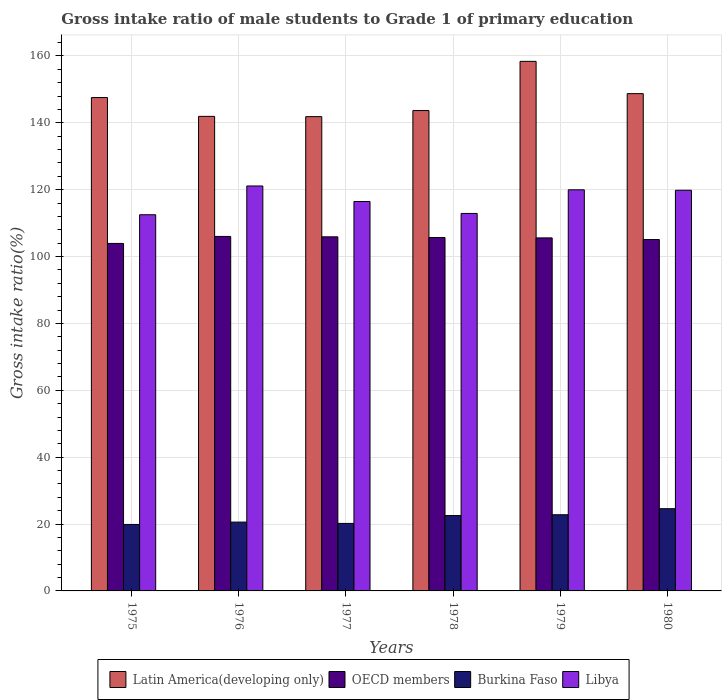Are the number of bars on each tick of the X-axis equal?
Your response must be concise. Yes. What is the label of the 1st group of bars from the left?
Keep it short and to the point. 1975. In how many cases, is the number of bars for a given year not equal to the number of legend labels?
Provide a short and direct response. 0. What is the gross intake ratio in Libya in 1979?
Make the answer very short. 119.96. Across all years, what is the maximum gross intake ratio in Libya?
Offer a very short reply. 121.1. Across all years, what is the minimum gross intake ratio in Burkina Faso?
Your answer should be compact. 19.88. In which year was the gross intake ratio in Libya maximum?
Make the answer very short. 1976. In which year was the gross intake ratio in Burkina Faso minimum?
Your answer should be very brief. 1975. What is the total gross intake ratio in Latin America(developing only) in the graph?
Your answer should be very brief. 882.04. What is the difference between the gross intake ratio in Latin America(developing only) in 1976 and that in 1980?
Your response must be concise. -6.8. What is the difference between the gross intake ratio in Burkina Faso in 1977 and the gross intake ratio in Libya in 1980?
Ensure brevity in your answer.  -99.63. What is the average gross intake ratio in OECD members per year?
Your answer should be very brief. 105.36. In the year 1976, what is the difference between the gross intake ratio in Burkina Faso and gross intake ratio in Libya?
Give a very brief answer. -100.52. In how many years, is the gross intake ratio in Latin America(developing only) greater than 128 %?
Keep it short and to the point. 6. What is the ratio of the gross intake ratio in Burkina Faso in 1979 to that in 1980?
Your answer should be very brief. 0.93. Is the gross intake ratio in Burkina Faso in 1978 less than that in 1979?
Your response must be concise. Yes. What is the difference between the highest and the second highest gross intake ratio in Libya?
Ensure brevity in your answer.  1.14. What is the difference between the highest and the lowest gross intake ratio in Libya?
Your answer should be very brief. 8.6. In how many years, is the gross intake ratio in Latin America(developing only) greater than the average gross intake ratio in Latin America(developing only) taken over all years?
Make the answer very short. 3. Is the sum of the gross intake ratio in OECD members in 1979 and 1980 greater than the maximum gross intake ratio in Burkina Faso across all years?
Offer a very short reply. Yes. What does the 4th bar from the right in 1978 represents?
Provide a succinct answer. Latin America(developing only). Is it the case that in every year, the sum of the gross intake ratio in OECD members and gross intake ratio in Latin America(developing only) is greater than the gross intake ratio in Burkina Faso?
Your answer should be very brief. Yes. Are all the bars in the graph horizontal?
Your answer should be compact. No. How many years are there in the graph?
Provide a succinct answer. 6. Does the graph contain grids?
Keep it short and to the point. Yes. How are the legend labels stacked?
Ensure brevity in your answer.  Horizontal. What is the title of the graph?
Provide a succinct answer. Gross intake ratio of male students to Grade 1 of primary education. Does "Madagascar" appear as one of the legend labels in the graph?
Make the answer very short. No. What is the label or title of the Y-axis?
Give a very brief answer. Gross intake ratio(%). What is the Gross intake ratio(%) in Latin America(developing only) in 1975?
Your answer should be compact. 147.54. What is the Gross intake ratio(%) of OECD members in 1975?
Provide a succinct answer. 103.92. What is the Gross intake ratio(%) of Burkina Faso in 1975?
Provide a short and direct response. 19.88. What is the Gross intake ratio(%) of Libya in 1975?
Ensure brevity in your answer.  112.5. What is the Gross intake ratio(%) of Latin America(developing only) in 1976?
Keep it short and to the point. 141.92. What is the Gross intake ratio(%) in OECD members in 1976?
Keep it short and to the point. 106.01. What is the Gross intake ratio(%) in Burkina Faso in 1976?
Make the answer very short. 20.58. What is the Gross intake ratio(%) of Libya in 1976?
Ensure brevity in your answer.  121.1. What is the Gross intake ratio(%) of Latin America(developing only) in 1977?
Your response must be concise. 141.84. What is the Gross intake ratio(%) in OECD members in 1977?
Give a very brief answer. 105.89. What is the Gross intake ratio(%) of Burkina Faso in 1977?
Make the answer very short. 20.19. What is the Gross intake ratio(%) in Libya in 1977?
Your answer should be compact. 116.46. What is the Gross intake ratio(%) in Latin America(developing only) in 1978?
Give a very brief answer. 143.65. What is the Gross intake ratio(%) in OECD members in 1978?
Your answer should be compact. 105.68. What is the Gross intake ratio(%) in Burkina Faso in 1978?
Your answer should be compact. 22.54. What is the Gross intake ratio(%) of Libya in 1978?
Provide a succinct answer. 112.89. What is the Gross intake ratio(%) of Latin America(developing only) in 1979?
Provide a succinct answer. 158.37. What is the Gross intake ratio(%) of OECD members in 1979?
Provide a succinct answer. 105.57. What is the Gross intake ratio(%) of Burkina Faso in 1979?
Make the answer very short. 22.78. What is the Gross intake ratio(%) of Libya in 1979?
Provide a succinct answer. 119.96. What is the Gross intake ratio(%) in Latin America(developing only) in 1980?
Your answer should be very brief. 148.72. What is the Gross intake ratio(%) in OECD members in 1980?
Offer a terse response. 105.08. What is the Gross intake ratio(%) of Burkina Faso in 1980?
Make the answer very short. 24.59. What is the Gross intake ratio(%) of Libya in 1980?
Ensure brevity in your answer.  119.82. Across all years, what is the maximum Gross intake ratio(%) in Latin America(developing only)?
Make the answer very short. 158.37. Across all years, what is the maximum Gross intake ratio(%) in OECD members?
Your answer should be compact. 106.01. Across all years, what is the maximum Gross intake ratio(%) in Burkina Faso?
Provide a short and direct response. 24.59. Across all years, what is the maximum Gross intake ratio(%) in Libya?
Offer a terse response. 121.1. Across all years, what is the minimum Gross intake ratio(%) of Latin America(developing only)?
Make the answer very short. 141.84. Across all years, what is the minimum Gross intake ratio(%) in OECD members?
Ensure brevity in your answer.  103.92. Across all years, what is the minimum Gross intake ratio(%) of Burkina Faso?
Your answer should be compact. 19.88. Across all years, what is the minimum Gross intake ratio(%) in Libya?
Your answer should be very brief. 112.5. What is the total Gross intake ratio(%) of Latin America(developing only) in the graph?
Your answer should be very brief. 882.04. What is the total Gross intake ratio(%) of OECD members in the graph?
Your answer should be very brief. 632.16. What is the total Gross intake ratio(%) of Burkina Faso in the graph?
Make the answer very short. 130.56. What is the total Gross intake ratio(%) of Libya in the graph?
Give a very brief answer. 702.72. What is the difference between the Gross intake ratio(%) in Latin America(developing only) in 1975 and that in 1976?
Provide a short and direct response. 5.63. What is the difference between the Gross intake ratio(%) of OECD members in 1975 and that in 1976?
Your response must be concise. -2.09. What is the difference between the Gross intake ratio(%) in Burkina Faso in 1975 and that in 1976?
Offer a terse response. -0.7. What is the difference between the Gross intake ratio(%) in Libya in 1975 and that in 1976?
Your answer should be compact. -8.6. What is the difference between the Gross intake ratio(%) in Latin America(developing only) in 1975 and that in 1977?
Offer a terse response. 5.7. What is the difference between the Gross intake ratio(%) of OECD members in 1975 and that in 1977?
Keep it short and to the point. -1.97. What is the difference between the Gross intake ratio(%) of Burkina Faso in 1975 and that in 1977?
Provide a short and direct response. -0.31. What is the difference between the Gross intake ratio(%) of Libya in 1975 and that in 1977?
Offer a terse response. -3.96. What is the difference between the Gross intake ratio(%) of Latin America(developing only) in 1975 and that in 1978?
Make the answer very short. 3.89. What is the difference between the Gross intake ratio(%) in OECD members in 1975 and that in 1978?
Give a very brief answer. -1.76. What is the difference between the Gross intake ratio(%) in Burkina Faso in 1975 and that in 1978?
Offer a terse response. -2.66. What is the difference between the Gross intake ratio(%) of Libya in 1975 and that in 1978?
Offer a terse response. -0.39. What is the difference between the Gross intake ratio(%) in Latin America(developing only) in 1975 and that in 1979?
Provide a short and direct response. -10.83. What is the difference between the Gross intake ratio(%) in OECD members in 1975 and that in 1979?
Ensure brevity in your answer.  -1.65. What is the difference between the Gross intake ratio(%) in Burkina Faso in 1975 and that in 1979?
Provide a succinct answer. -2.9. What is the difference between the Gross intake ratio(%) in Libya in 1975 and that in 1979?
Provide a succinct answer. -7.45. What is the difference between the Gross intake ratio(%) in Latin America(developing only) in 1975 and that in 1980?
Your response must be concise. -1.17. What is the difference between the Gross intake ratio(%) in OECD members in 1975 and that in 1980?
Offer a very short reply. -1.16. What is the difference between the Gross intake ratio(%) of Burkina Faso in 1975 and that in 1980?
Make the answer very short. -4.71. What is the difference between the Gross intake ratio(%) of Libya in 1975 and that in 1980?
Give a very brief answer. -7.32. What is the difference between the Gross intake ratio(%) of Latin America(developing only) in 1976 and that in 1977?
Give a very brief answer. 0.08. What is the difference between the Gross intake ratio(%) of OECD members in 1976 and that in 1977?
Offer a very short reply. 0.12. What is the difference between the Gross intake ratio(%) in Burkina Faso in 1976 and that in 1977?
Your response must be concise. 0.4. What is the difference between the Gross intake ratio(%) of Libya in 1976 and that in 1977?
Keep it short and to the point. 4.64. What is the difference between the Gross intake ratio(%) in Latin America(developing only) in 1976 and that in 1978?
Offer a terse response. -1.74. What is the difference between the Gross intake ratio(%) of OECD members in 1976 and that in 1978?
Ensure brevity in your answer.  0.33. What is the difference between the Gross intake ratio(%) of Burkina Faso in 1976 and that in 1978?
Keep it short and to the point. -1.95. What is the difference between the Gross intake ratio(%) of Libya in 1976 and that in 1978?
Your response must be concise. 8.21. What is the difference between the Gross intake ratio(%) of Latin America(developing only) in 1976 and that in 1979?
Give a very brief answer. -16.45. What is the difference between the Gross intake ratio(%) in OECD members in 1976 and that in 1979?
Your response must be concise. 0.44. What is the difference between the Gross intake ratio(%) in Burkina Faso in 1976 and that in 1979?
Keep it short and to the point. -2.2. What is the difference between the Gross intake ratio(%) in Libya in 1976 and that in 1979?
Your answer should be compact. 1.14. What is the difference between the Gross intake ratio(%) in Latin America(developing only) in 1976 and that in 1980?
Keep it short and to the point. -6.8. What is the difference between the Gross intake ratio(%) in Burkina Faso in 1976 and that in 1980?
Offer a terse response. -4.01. What is the difference between the Gross intake ratio(%) of Libya in 1976 and that in 1980?
Your answer should be very brief. 1.28. What is the difference between the Gross intake ratio(%) of Latin America(developing only) in 1977 and that in 1978?
Provide a short and direct response. -1.81. What is the difference between the Gross intake ratio(%) in OECD members in 1977 and that in 1978?
Make the answer very short. 0.21. What is the difference between the Gross intake ratio(%) of Burkina Faso in 1977 and that in 1978?
Provide a short and direct response. -2.35. What is the difference between the Gross intake ratio(%) in Libya in 1977 and that in 1978?
Your answer should be very brief. 3.57. What is the difference between the Gross intake ratio(%) of Latin America(developing only) in 1977 and that in 1979?
Provide a short and direct response. -16.53. What is the difference between the Gross intake ratio(%) of OECD members in 1977 and that in 1979?
Provide a short and direct response. 0.32. What is the difference between the Gross intake ratio(%) of Burkina Faso in 1977 and that in 1979?
Keep it short and to the point. -2.6. What is the difference between the Gross intake ratio(%) of Libya in 1977 and that in 1979?
Your response must be concise. -3.5. What is the difference between the Gross intake ratio(%) in Latin America(developing only) in 1977 and that in 1980?
Keep it short and to the point. -6.88. What is the difference between the Gross intake ratio(%) of OECD members in 1977 and that in 1980?
Provide a succinct answer. 0.81. What is the difference between the Gross intake ratio(%) in Burkina Faso in 1977 and that in 1980?
Ensure brevity in your answer.  -4.4. What is the difference between the Gross intake ratio(%) in Libya in 1977 and that in 1980?
Your answer should be compact. -3.36. What is the difference between the Gross intake ratio(%) in Latin America(developing only) in 1978 and that in 1979?
Make the answer very short. -14.72. What is the difference between the Gross intake ratio(%) of Burkina Faso in 1978 and that in 1979?
Your answer should be compact. -0.24. What is the difference between the Gross intake ratio(%) in Libya in 1978 and that in 1979?
Provide a succinct answer. -7.07. What is the difference between the Gross intake ratio(%) of Latin America(developing only) in 1978 and that in 1980?
Offer a terse response. -5.06. What is the difference between the Gross intake ratio(%) in OECD members in 1978 and that in 1980?
Offer a very short reply. 0.6. What is the difference between the Gross intake ratio(%) of Burkina Faso in 1978 and that in 1980?
Offer a very short reply. -2.05. What is the difference between the Gross intake ratio(%) of Libya in 1978 and that in 1980?
Keep it short and to the point. -6.93. What is the difference between the Gross intake ratio(%) of Latin America(developing only) in 1979 and that in 1980?
Your answer should be very brief. 9.65. What is the difference between the Gross intake ratio(%) in OECD members in 1979 and that in 1980?
Provide a succinct answer. 0.49. What is the difference between the Gross intake ratio(%) of Burkina Faso in 1979 and that in 1980?
Ensure brevity in your answer.  -1.81. What is the difference between the Gross intake ratio(%) of Libya in 1979 and that in 1980?
Provide a short and direct response. 0.13. What is the difference between the Gross intake ratio(%) of Latin America(developing only) in 1975 and the Gross intake ratio(%) of OECD members in 1976?
Provide a succinct answer. 41.53. What is the difference between the Gross intake ratio(%) in Latin America(developing only) in 1975 and the Gross intake ratio(%) in Burkina Faso in 1976?
Your answer should be compact. 126.96. What is the difference between the Gross intake ratio(%) in Latin America(developing only) in 1975 and the Gross intake ratio(%) in Libya in 1976?
Make the answer very short. 26.44. What is the difference between the Gross intake ratio(%) in OECD members in 1975 and the Gross intake ratio(%) in Burkina Faso in 1976?
Your answer should be very brief. 83.34. What is the difference between the Gross intake ratio(%) in OECD members in 1975 and the Gross intake ratio(%) in Libya in 1976?
Offer a terse response. -17.18. What is the difference between the Gross intake ratio(%) in Burkina Faso in 1975 and the Gross intake ratio(%) in Libya in 1976?
Your answer should be compact. -101.22. What is the difference between the Gross intake ratio(%) in Latin America(developing only) in 1975 and the Gross intake ratio(%) in OECD members in 1977?
Your response must be concise. 41.65. What is the difference between the Gross intake ratio(%) in Latin America(developing only) in 1975 and the Gross intake ratio(%) in Burkina Faso in 1977?
Keep it short and to the point. 127.36. What is the difference between the Gross intake ratio(%) of Latin America(developing only) in 1975 and the Gross intake ratio(%) of Libya in 1977?
Your response must be concise. 31.08. What is the difference between the Gross intake ratio(%) of OECD members in 1975 and the Gross intake ratio(%) of Burkina Faso in 1977?
Your answer should be very brief. 83.73. What is the difference between the Gross intake ratio(%) in OECD members in 1975 and the Gross intake ratio(%) in Libya in 1977?
Your response must be concise. -12.54. What is the difference between the Gross intake ratio(%) of Burkina Faso in 1975 and the Gross intake ratio(%) of Libya in 1977?
Offer a very short reply. -96.58. What is the difference between the Gross intake ratio(%) in Latin America(developing only) in 1975 and the Gross intake ratio(%) in OECD members in 1978?
Give a very brief answer. 41.86. What is the difference between the Gross intake ratio(%) of Latin America(developing only) in 1975 and the Gross intake ratio(%) of Burkina Faso in 1978?
Provide a succinct answer. 125. What is the difference between the Gross intake ratio(%) in Latin America(developing only) in 1975 and the Gross intake ratio(%) in Libya in 1978?
Provide a short and direct response. 34.66. What is the difference between the Gross intake ratio(%) in OECD members in 1975 and the Gross intake ratio(%) in Burkina Faso in 1978?
Offer a very short reply. 81.38. What is the difference between the Gross intake ratio(%) of OECD members in 1975 and the Gross intake ratio(%) of Libya in 1978?
Make the answer very short. -8.97. What is the difference between the Gross intake ratio(%) in Burkina Faso in 1975 and the Gross intake ratio(%) in Libya in 1978?
Make the answer very short. -93.01. What is the difference between the Gross intake ratio(%) in Latin America(developing only) in 1975 and the Gross intake ratio(%) in OECD members in 1979?
Your response must be concise. 41.97. What is the difference between the Gross intake ratio(%) in Latin America(developing only) in 1975 and the Gross intake ratio(%) in Burkina Faso in 1979?
Offer a very short reply. 124.76. What is the difference between the Gross intake ratio(%) in Latin America(developing only) in 1975 and the Gross intake ratio(%) in Libya in 1979?
Make the answer very short. 27.59. What is the difference between the Gross intake ratio(%) of OECD members in 1975 and the Gross intake ratio(%) of Burkina Faso in 1979?
Offer a terse response. 81.14. What is the difference between the Gross intake ratio(%) in OECD members in 1975 and the Gross intake ratio(%) in Libya in 1979?
Keep it short and to the point. -16.04. What is the difference between the Gross intake ratio(%) of Burkina Faso in 1975 and the Gross intake ratio(%) of Libya in 1979?
Your answer should be compact. -100.07. What is the difference between the Gross intake ratio(%) of Latin America(developing only) in 1975 and the Gross intake ratio(%) of OECD members in 1980?
Give a very brief answer. 42.46. What is the difference between the Gross intake ratio(%) of Latin America(developing only) in 1975 and the Gross intake ratio(%) of Burkina Faso in 1980?
Offer a very short reply. 122.95. What is the difference between the Gross intake ratio(%) in Latin America(developing only) in 1975 and the Gross intake ratio(%) in Libya in 1980?
Your answer should be very brief. 27.72. What is the difference between the Gross intake ratio(%) of OECD members in 1975 and the Gross intake ratio(%) of Burkina Faso in 1980?
Make the answer very short. 79.33. What is the difference between the Gross intake ratio(%) in OECD members in 1975 and the Gross intake ratio(%) in Libya in 1980?
Offer a very short reply. -15.9. What is the difference between the Gross intake ratio(%) in Burkina Faso in 1975 and the Gross intake ratio(%) in Libya in 1980?
Your answer should be compact. -99.94. What is the difference between the Gross intake ratio(%) of Latin America(developing only) in 1976 and the Gross intake ratio(%) of OECD members in 1977?
Offer a terse response. 36.02. What is the difference between the Gross intake ratio(%) in Latin America(developing only) in 1976 and the Gross intake ratio(%) in Burkina Faso in 1977?
Make the answer very short. 121.73. What is the difference between the Gross intake ratio(%) of Latin America(developing only) in 1976 and the Gross intake ratio(%) of Libya in 1977?
Keep it short and to the point. 25.46. What is the difference between the Gross intake ratio(%) in OECD members in 1976 and the Gross intake ratio(%) in Burkina Faso in 1977?
Make the answer very short. 85.83. What is the difference between the Gross intake ratio(%) in OECD members in 1976 and the Gross intake ratio(%) in Libya in 1977?
Offer a terse response. -10.45. What is the difference between the Gross intake ratio(%) in Burkina Faso in 1976 and the Gross intake ratio(%) in Libya in 1977?
Offer a terse response. -95.88. What is the difference between the Gross intake ratio(%) in Latin America(developing only) in 1976 and the Gross intake ratio(%) in OECD members in 1978?
Offer a terse response. 36.23. What is the difference between the Gross intake ratio(%) of Latin America(developing only) in 1976 and the Gross intake ratio(%) of Burkina Faso in 1978?
Provide a succinct answer. 119.38. What is the difference between the Gross intake ratio(%) in Latin America(developing only) in 1976 and the Gross intake ratio(%) in Libya in 1978?
Keep it short and to the point. 29.03. What is the difference between the Gross intake ratio(%) in OECD members in 1976 and the Gross intake ratio(%) in Burkina Faso in 1978?
Your answer should be very brief. 83.47. What is the difference between the Gross intake ratio(%) in OECD members in 1976 and the Gross intake ratio(%) in Libya in 1978?
Your answer should be very brief. -6.88. What is the difference between the Gross intake ratio(%) of Burkina Faso in 1976 and the Gross intake ratio(%) of Libya in 1978?
Your answer should be compact. -92.3. What is the difference between the Gross intake ratio(%) of Latin America(developing only) in 1976 and the Gross intake ratio(%) of OECD members in 1979?
Make the answer very short. 36.34. What is the difference between the Gross intake ratio(%) of Latin America(developing only) in 1976 and the Gross intake ratio(%) of Burkina Faso in 1979?
Keep it short and to the point. 119.14. What is the difference between the Gross intake ratio(%) of Latin America(developing only) in 1976 and the Gross intake ratio(%) of Libya in 1979?
Provide a short and direct response. 21.96. What is the difference between the Gross intake ratio(%) in OECD members in 1976 and the Gross intake ratio(%) in Burkina Faso in 1979?
Ensure brevity in your answer.  83.23. What is the difference between the Gross intake ratio(%) in OECD members in 1976 and the Gross intake ratio(%) in Libya in 1979?
Give a very brief answer. -13.94. What is the difference between the Gross intake ratio(%) of Burkina Faso in 1976 and the Gross intake ratio(%) of Libya in 1979?
Keep it short and to the point. -99.37. What is the difference between the Gross intake ratio(%) of Latin America(developing only) in 1976 and the Gross intake ratio(%) of OECD members in 1980?
Offer a terse response. 36.83. What is the difference between the Gross intake ratio(%) of Latin America(developing only) in 1976 and the Gross intake ratio(%) of Burkina Faso in 1980?
Your response must be concise. 117.33. What is the difference between the Gross intake ratio(%) of Latin America(developing only) in 1976 and the Gross intake ratio(%) of Libya in 1980?
Ensure brevity in your answer.  22.1. What is the difference between the Gross intake ratio(%) in OECD members in 1976 and the Gross intake ratio(%) in Burkina Faso in 1980?
Provide a succinct answer. 81.42. What is the difference between the Gross intake ratio(%) in OECD members in 1976 and the Gross intake ratio(%) in Libya in 1980?
Give a very brief answer. -13.81. What is the difference between the Gross intake ratio(%) in Burkina Faso in 1976 and the Gross intake ratio(%) in Libya in 1980?
Provide a short and direct response. -99.24. What is the difference between the Gross intake ratio(%) of Latin America(developing only) in 1977 and the Gross intake ratio(%) of OECD members in 1978?
Make the answer very short. 36.16. What is the difference between the Gross intake ratio(%) of Latin America(developing only) in 1977 and the Gross intake ratio(%) of Burkina Faso in 1978?
Keep it short and to the point. 119.3. What is the difference between the Gross intake ratio(%) in Latin America(developing only) in 1977 and the Gross intake ratio(%) in Libya in 1978?
Your response must be concise. 28.95. What is the difference between the Gross intake ratio(%) of OECD members in 1977 and the Gross intake ratio(%) of Burkina Faso in 1978?
Your response must be concise. 83.35. What is the difference between the Gross intake ratio(%) of OECD members in 1977 and the Gross intake ratio(%) of Libya in 1978?
Your answer should be very brief. -6.99. What is the difference between the Gross intake ratio(%) of Burkina Faso in 1977 and the Gross intake ratio(%) of Libya in 1978?
Offer a very short reply. -92.7. What is the difference between the Gross intake ratio(%) of Latin America(developing only) in 1977 and the Gross intake ratio(%) of OECD members in 1979?
Make the answer very short. 36.27. What is the difference between the Gross intake ratio(%) in Latin America(developing only) in 1977 and the Gross intake ratio(%) in Burkina Faso in 1979?
Provide a succinct answer. 119.06. What is the difference between the Gross intake ratio(%) of Latin America(developing only) in 1977 and the Gross intake ratio(%) of Libya in 1979?
Provide a short and direct response. 21.89. What is the difference between the Gross intake ratio(%) in OECD members in 1977 and the Gross intake ratio(%) in Burkina Faso in 1979?
Make the answer very short. 83.11. What is the difference between the Gross intake ratio(%) in OECD members in 1977 and the Gross intake ratio(%) in Libya in 1979?
Ensure brevity in your answer.  -14.06. What is the difference between the Gross intake ratio(%) in Burkina Faso in 1977 and the Gross intake ratio(%) in Libya in 1979?
Offer a very short reply. -99.77. What is the difference between the Gross intake ratio(%) in Latin America(developing only) in 1977 and the Gross intake ratio(%) in OECD members in 1980?
Make the answer very short. 36.76. What is the difference between the Gross intake ratio(%) in Latin America(developing only) in 1977 and the Gross intake ratio(%) in Burkina Faso in 1980?
Provide a succinct answer. 117.25. What is the difference between the Gross intake ratio(%) of Latin America(developing only) in 1977 and the Gross intake ratio(%) of Libya in 1980?
Give a very brief answer. 22.02. What is the difference between the Gross intake ratio(%) in OECD members in 1977 and the Gross intake ratio(%) in Burkina Faso in 1980?
Provide a succinct answer. 81.3. What is the difference between the Gross intake ratio(%) of OECD members in 1977 and the Gross intake ratio(%) of Libya in 1980?
Provide a succinct answer. -13.93. What is the difference between the Gross intake ratio(%) in Burkina Faso in 1977 and the Gross intake ratio(%) in Libya in 1980?
Your answer should be very brief. -99.63. What is the difference between the Gross intake ratio(%) in Latin America(developing only) in 1978 and the Gross intake ratio(%) in OECD members in 1979?
Provide a short and direct response. 38.08. What is the difference between the Gross intake ratio(%) in Latin America(developing only) in 1978 and the Gross intake ratio(%) in Burkina Faso in 1979?
Keep it short and to the point. 120.87. What is the difference between the Gross intake ratio(%) in Latin America(developing only) in 1978 and the Gross intake ratio(%) in Libya in 1979?
Offer a very short reply. 23.7. What is the difference between the Gross intake ratio(%) in OECD members in 1978 and the Gross intake ratio(%) in Burkina Faso in 1979?
Make the answer very short. 82.9. What is the difference between the Gross intake ratio(%) in OECD members in 1978 and the Gross intake ratio(%) in Libya in 1979?
Your response must be concise. -14.27. What is the difference between the Gross intake ratio(%) in Burkina Faso in 1978 and the Gross intake ratio(%) in Libya in 1979?
Give a very brief answer. -97.42. What is the difference between the Gross intake ratio(%) of Latin America(developing only) in 1978 and the Gross intake ratio(%) of OECD members in 1980?
Provide a short and direct response. 38.57. What is the difference between the Gross intake ratio(%) in Latin America(developing only) in 1978 and the Gross intake ratio(%) in Burkina Faso in 1980?
Give a very brief answer. 119.06. What is the difference between the Gross intake ratio(%) in Latin America(developing only) in 1978 and the Gross intake ratio(%) in Libya in 1980?
Offer a terse response. 23.83. What is the difference between the Gross intake ratio(%) in OECD members in 1978 and the Gross intake ratio(%) in Burkina Faso in 1980?
Ensure brevity in your answer.  81.09. What is the difference between the Gross intake ratio(%) in OECD members in 1978 and the Gross intake ratio(%) in Libya in 1980?
Your answer should be very brief. -14.14. What is the difference between the Gross intake ratio(%) of Burkina Faso in 1978 and the Gross intake ratio(%) of Libya in 1980?
Your answer should be very brief. -97.28. What is the difference between the Gross intake ratio(%) of Latin America(developing only) in 1979 and the Gross intake ratio(%) of OECD members in 1980?
Offer a terse response. 53.29. What is the difference between the Gross intake ratio(%) of Latin America(developing only) in 1979 and the Gross intake ratio(%) of Burkina Faso in 1980?
Offer a very short reply. 133.78. What is the difference between the Gross intake ratio(%) of Latin America(developing only) in 1979 and the Gross intake ratio(%) of Libya in 1980?
Your response must be concise. 38.55. What is the difference between the Gross intake ratio(%) in OECD members in 1979 and the Gross intake ratio(%) in Burkina Faso in 1980?
Make the answer very short. 80.98. What is the difference between the Gross intake ratio(%) in OECD members in 1979 and the Gross intake ratio(%) in Libya in 1980?
Ensure brevity in your answer.  -14.25. What is the difference between the Gross intake ratio(%) of Burkina Faso in 1979 and the Gross intake ratio(%) of Libya in 1980?
Your response must be concise. -97.04. What is the average Gross intake ratio(%) in Latin America(developing only) per year?
Your answer should be compact. 147.01. What is the average Gross intake ratio(%) of OECD members per year?
Your answer should be compact. 105.36. What is the average Gross intake ratio(%) in Burkina Faso per year?
Provide a short and direct response. 21.76. What is the average Gross intake ratio(%) in Libya per year?
Give a very brief answer. 117.12. In the year 1975, what is the difference between the Gross intake ratio(%) of Latin America(developing only) and Gross intake ratio(%) of OECD members?
Your answer should be compact. 43.62. In the year 1975, what is the difference between the Gross intake ratio(%) in Latin America(developing only) and Gross intake ratio(%) in Burkina Faso?
Give a very brief answer. 127.66. In the year 1975, what is the difference between the Gross intake ratio(%) of Latin America(developing only) and Gross intake ratio(%) of Libya?
Ensure brevity in your answer.  35.04. In the year 1975, what is the difference between the Gross intake ratio(%) in OECD members and Gross intake ratio(%) in Burkina Faso?
Your answer should be compact. 84.04. In the year 1975, what is the difference between the Gross intake ratio(%) in OECD members and Gross intake ratio(%) in Libya?
Your response must be concise. -8.58. In the year 1975, what is the difference between the Gross intake ratio(%) in Burkina Faso and Gross intake ratio(%) in Libya?
Make the answer very short. -92.62. In the year 1976, what is the difference between the Gross intake ratio(%) of Latin America(developing only) and Gross intake ratio(%) of OECD members?
Your response must be concise. 35.91. In the year 1976, what is the difference between the Gross intake ratio(%) in Latin America(developing only) and Gross intake ratio(%) in Burkina Faso?
Offer a terse response. 121.33. In the year 1976, what is the difference between the Gross intake ratio(%) in Latin America(developing only) and Gross intake ratio(%) in Libya?
Keep it short and to the point. 20.82. In the year 1976, what is the difference between the Gross intake ratio(%) of OECD members and Gross intake ratio(%) of Burkina Faso?
Your response must be concise. 85.43. In the year 1976, what is the difference between the Gross intake ratio(%) in OECD members and Gross intake ratio(%) in Libya?
Offer a terse response. -15.09. In the year 1976, what is the difference between the Gross intake ratio(%) of Burkina Faso and Gross intake ratio(%) of Libya?
Offer a very short reply. -100.52. In the year 1977, what is the difference between the Gross intake ratio(%) in Latin America(developing only) and Gross intake ratio(%) in OECD members?
Provide a succinct answer. 35.95. In the year 1977, what is the difference between the Gross intake ratio(%) of Latin America(developing only) and Gross intake ratio(%) of Burkina Faso?
Ensure brevity in your answer.  121.65. In the year 1977, what is the difference between the Gross intake ratio(%) of Latin America(developing only) and Gross intake ratio(%) of Libya?
Offer a terse response. 25.38. In the year 1977, what is the difference between the Gross intake ratio(%) in OECD members and Gross intake ratio(%) in Burkina Faso?
Offer a very short reply. 85.71. In the year 1977, what is the difference between the Gross intake ratio(%) in OECD members and Gross intake ratio(%) in Libya?
Offer a very short reply. -10.57. In the year 1977, what is the difference between the Gross intake ratio(%) of Burkina Faso and Gross intake ratio(%) of Libya?
Give a very brief answer. -96.27. In the year 1978, what is the difference between the Gross intake ratio(%) of Latin America(developing only) and Gross intake ratio(%) of OECD members?
Make the answer very short. 37.97. In the year 1978, what is the difference between the Gross intake ratio(%) of Latin America(developing only) and Gross intake ratio(%) of Burkina Faso?
Your answer should be very brief. 121.12. In the year 1978, what is the difference between the Gross intake ratio(%) of Latin America(developing only) and Gross intake ratio(%) of Libya?
Ensure brevity in your answer.  30.77. In the year 1978, what is the difference between the Gross intake ratio(%) of OECD members and Gross intake ratio(%) of Burkina Faso?
Your answer should be very brief. 83.15. In the year 1978, what is the difference between the Gross intake ratio(%) of OECD members and Gross intake ratio(%) of Libya?
Offer a very short reply. -7.2. In the year 1978, what is the difference between the Gross intake ratio(%) of Burkina Faso and Gross intake ratio(%) of Libya?
Ensure brevity in your answer.  -90.35. In the year 1979, what is the difference between the Gross intake ratio(%) of Latin America(developing only) and Gross intake ratio(%) of OECD members?
Make the answer very short. 52.8. In the year 1979, what is the difference between the Gross intake ratio(%) of Latin America(developing only) and Gross intake ratio(%) of Burkina Faso?
Offer a very short reply. 135.59. In the year 1979, what is the difference between the Gross intake ratio(%) in Latin America(developing only) and Gross intake ratio(%) in Libya?
Offer a terse response. 38.41. In the year 1979, what is the difference between the Gross intake ratio(%) in OECD members and Gross intake ratio(%) in Burkina Faso?
Ensure brevity in your answer.  82.79. In the year 1979, what is the difference between the Gross intake ratio(%) in OECD members and Gross intake ratio(%) in Libya?
Offer a terse response. -14.38. In the year 1979, what is the difference between the Gross intake ratio(%) of Burkina Faso and Gross intake ratio(%) of Libya?
Provide a short and direct response. -97.17. In the year 1980, what is the difference between the Gross intake ratio(%) in Latin America(developing only) and Gross intake ratio(%) in OECD members?
Your answer should be very brief. 43.63. In the year 1980, what is the difference between the Gross intake ratio(%) of Latin America(developing only) and Gross intake ratio(%) of Burkina Faso?
Provide a short and direct response. 124.13. In the year 1980, what is the difference between the Gross intake ratio(%) of Latin America(developing only) and Gross intake ratio(%) of Libya?
Provide a succinct answer. 28.9. In the year 1980, what is the difference between the Gross intake ratio(%) in OECD members and Gross intake ratio(%) in Burkina Faso?
Make the answer very short. 80.49. In the year 1980, what is the difference between the Gross intake ratio(%) in OECD members and Gross intake ratio(%) in Libya?
Offer a very short reply. -14.74. In the year 1980, what is the difference between the Gross intake ratio(%) in Burkina Faso and Gross intake ratio(%) in Libya?
Your response must be concise. -95.23. What is the ratio of the Gross intake ratio(%) in Latin America(developing only) in 1975 to that in 1976?
Your response must be concise. 1.04. What is the ratio of the Gross intake ratio(%) in OECD members in 1975 to that in 1976?
Your answer should be compact. 0.98. What is the ratio of the Gross intake ratio(%) in Burkina Faso in 1975 to that in 1976?
Give a very brief answer. 0.97. What is the ratio of the Gross intake ratio(%) in Libya in 1975 to that in 1976?
Offer a very short reply. 0.93. What is the ratio of the Gross intake ratio(%) in Latin America(developing only) in 1975 to that in 1977?
Make the answer very short. 1.04. What is the ratio of the Gross intake ratio(%) in OECD members in 1975 to that in 1977?
Your response must be concise. 0.98. What is the ratio of the Gross intake ratio(%) in Burkina Faso in 1975 to that in 1977?
Offer a very short reply. 0.98. What is the ratio of the Gross intake ratio(%) of Latin America(developing only) in 1975 to that in 1978?
Your answer should be very brief. 1.03. What is the ratio of the Gross intake ratio(%) of OECD members in 1975 to that in 1978?
Provide a short and direct response. 0.98. What is the ratio of the Gross intake ratio(%) in Burkina Faso in 1975 to that in 1978?
Your answer should be very brief. 0.88. What is the ratio of the Gross intake ratio(%) of Libya in 1975 to that in 1978?
Offer a very short reply. 1. What is the ratio of the Gross intake ratio(%) of Latin America(developing only) in 1975 to that in 1979?
Offer a very short reply. 0.93. What is the ratio of the Gross intake ratio(%) in OECD members in 1975 to that in 1979?
Keep it short and to the point. 0.98. What is the ratio of the Gross intake ratio(%) of Burkina Faso in 1975 to that in 1979?
Ensure brevity in your answer.  0.87. What is the ratio of the Gross intake ratio(%) of Libya in 1975 to that in 1979?
Ensure brevity in your answer.  0.94. What is the ratio of the Gross intake ratio(%) of Latin America(developing only) in 1975 to that in 1980?
Your response must be concise. 0.99. What is the ratio of the Gross intake ratio(%) of OECD members in 1975 to that in 1980?
Offer a terse response. 0.99. What is the ratio of the Gross intake ratio(%) of Burkina Faso in 1975 to that in 1980?
Ensure brevity in your answer.  0.81. What is the ratio of the Gross intake ratio(%) of Libya in 1975 to that in 1980?
Your answer should be compact. 0.94. What is the ratio of the Gross intake ratio(%) in Burkina Faso in 1976 to that in 1977?
Your response must be concise. 1.02. What is the ratio of the Gross intake ratio(%) in Libya in 1976 to that in 1977?
Offer a terse response. 1.04. What is the ratio of the Gross intake ratio(%) in Latin America(developing only) in 1976 to that in 1978?
Keep it short and to the point. 0.99. What is the ratio of the Gross intake ratio(%) of OECD members in 1976 to that in 1978?
Offer a terse response. 1. What is the ratio of the Gross intake ratio(%) of Burkina Faso in 1976 to that in 1978?
Provide a succinct answer. 0.91. What is the ratio of the Gross intake ratio(%) in Libya in 1976 to that in 1978?
Keep it short and to the point. 1.07. What is the ratio of the Gross intake ratio(%) of Latin America(developing only) in 1976 to that in 1979?
Ensure brevity in your answer.  0.9. What is the ratio of the Gross intake ratio(%) of Burkina Faso in 1976 to that in 1979?
Make the answer very short. 0.9. What is the ratio of the Gross intake ratio(%) in Libya in 1976 to that in 1979?
Your answer should be very brief. 1.01. What is the ratio of the Gross intake ratio(%) of Latin America(developing only) in 1976 to that in 1980?
Give a very brief answer. 0.95. What is the ratio of the Gross intake ratio(%) in OECD members in 1976 to that in 1980?
Give a very brief answer. 1.01. What is the ratio of the Gross intake ratio(%) of Burkina Faso in 1976 to that in 1980?
Your answer should be very brief. 0.84. What is the ratio of the Gross intake ratio(%) in Libya in 1976 to that in 1980?
Provide a short and direct response. 1.01. What is the ratio of the Gross intake ratio(%) in Latin America(developing only) in 1977 to that in 1978?
Offer a very short reply. 0.99. What is the ratio of the Gross intake ratio(%) of Burkina Faso in 1977 to that in 1978?
Provide a succinct answer. 0.9. What is the ratio of the Gross intake ratio(%) of Libya in 1977 to that in 1978?
Offer a very short reply. 1.03. What is the ratio of the Gross intake ratio(%) of Latin America(developing only) in 1977 to that in 1979?
Provide a short and direct response. 0.9. What is the ratio of the Gross intake ratio(%) in OECD members in 1977 to that in 1979?
Your response must be concise. 1. What is the ratio of the Gross intake ratio(%) in Burkina Faso in 1977 to that in 1979?
Your answer should be compact. 0.89. What is the ratio of the Gross intake ratio(%) in Libya in 1977 to that in 1979?
Provide a short and direct response. 0.97. What is the ratio of the Gross intake ratio(%) of Latin America(developing only) in 1977 to that in 1980?
Provide a succinct answer. 0.95. What is the ratio of the Gross intake ratio(%) in OECD members in 1977 to that in 1980?
Offer a very short reply. 1.01. What is the ratio of the Gross intake ratio(%) in Burkina Faso in 1977 to that in 1980?
Your response must be concise. 0.82. What is the ratio of the Gross intake ratio(%) of Libya in 1977 to that in 1980?
Keep it short and to the point. 0.97. What is the ratio of the Gross intake ratio(%) in Latin America(developing only) in 1978 to that in 1979?
Your answer should be compact. 0.91. What is the ratio of the Gross intake ratio(%) of Burkina Faso in 1978 to that in 1979?
Offer a very short reply. 0.99. What is the ratio of the Gross intake ratio(%) in Libya in 1978 to that in 1979?
Provide a succinct answer. 0.94. What is the ratio of the Gross intake ratio(%) in Burkina Faso in 1978 to that in 1980?
Give a very brief answer. 0.92. What is the ratio of the Gross intake ratio(%) of Libya in 1978 to that in 1980?
Your answer should be very brief. 0.94. What is the ratio of the Gross intake ratio(%) of Latin America(developing only) in 1979 to that in 1980?
Keep it short and to the point. 1.06. What is the ratio of the Gross intake ratio(%) of Burkina Faso in 1979 to that in 1980?
Give a very brief answer. 0.93. What is the difference between the highest and the second highest Gross intake ratio(%) in Latin America(developing only)?
Ensure brevity in your answer.  9.65. What is the difference between the highest and the second highest Gross intake ratio(%) of OECD members?
Keep it short and to the point. 0.12. What is the difference between the highest and the second highest Gross intake ratio(%) in Burkina Faso?
Make the answer very short. 1.81. What is the difference between the highest and the second highest Gross intake ratio(%) in Libya?
Offer a very short reply. 1.14. What is the difference between the highest and the lowest Gross intake ratio(%) of Latin America(developing only)?
Make the answer very short. 16.53. What is the difference between the highest and the lowest Gross intake ratio(%) in OECD members?
Keep it short and to the point. 2.09. What is the difference between the highest and the lowest Gross intake ratio(%) in Burkina Faso?
Your answer should be very brief. 4.71. What is the difference between the highest and the lowest Gross intake ratio(%) in Libya?
Keep it short and to the point. 8.6. 